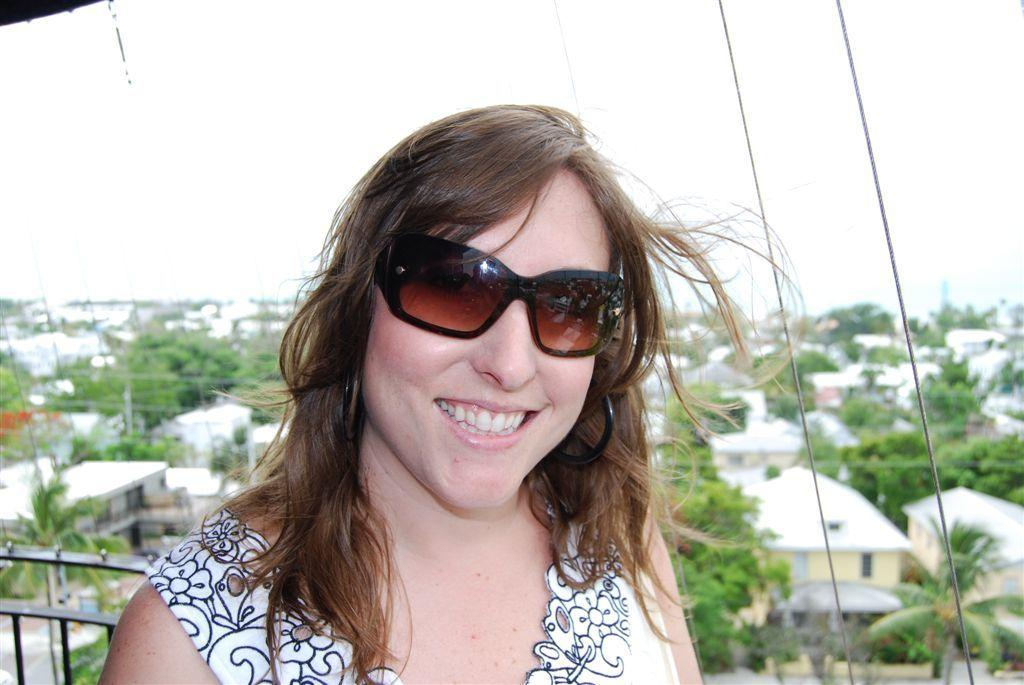Who is the main subject in the foreground of the image? There is a woman in the foreground of the image. What is the woman's expression in the image? The woman is smiling in the image. What can be seen in the background of the image? There are houses and trees in the background of the image. What objects are on the right side of the image? There are two ropes on the right side of the image. What type of underwear is the woman wearing in the image? There is no information about the woman's underwear in the image, and it is not visible. Who is the woman's crush in the image? There is no information about a crush or any romantic interest in the image. 